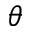Convert formula to latex. <formula><loc_0><loc_0><loc_500><loc_500>\theta</formula> 